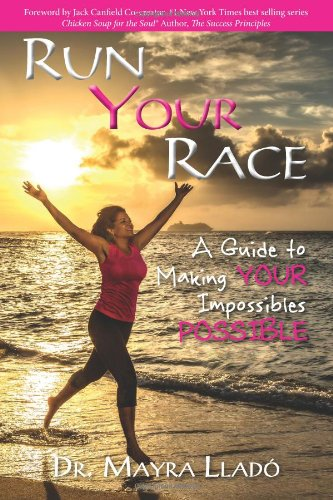Who wrote this book?
Answer the question using a single word or phrase. Dr. Mayra Llado What is the title of this book? Run Your Race: A Guide to Making Your Impossibles Possible What is the genre of this book? Self-Help Is this book related to Self-Help? Yes Is this book related to Literature & Fiction? No 